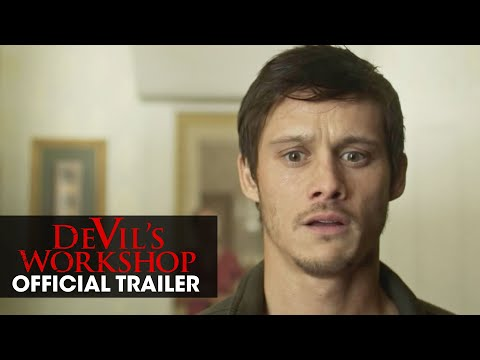If the painting on the wall could come to life, what would it say or do in this scene? The painting, filled with vibrant colors and abstract shapes, suddenly animates. A figure within the painting steps out and says, "Finally, I can stretch my legs! It's been centuries since I was trapped in that frame. Now, mortals, what brings you here to this realm of twisted artistry?" Create a scenario where the image is part of an alternate universe where artworks can interact with humans. In an alternate universe where artworks can interact with humans, the man in the image finds himself in an art gallery where each piece of art starts speaking to him. The painting on the wall beside him, an ethereal landscape, begins to narrate its history: "I was created in the mind of a tormented artist seeking solace in nature. Through the strokes of the brush, I captured the essence of serenity and madness. What secrets do you seek from me, traveler?" Entranced, the man replies, "I seek guidance. This artifact we found... it's behaving strangely." The landscape shifts, forming symbols and paths. "Follow the river of time," the painting advises. "Only there, you'll uncover the truth. But beware, the journey is fraught with peril and discovery." 